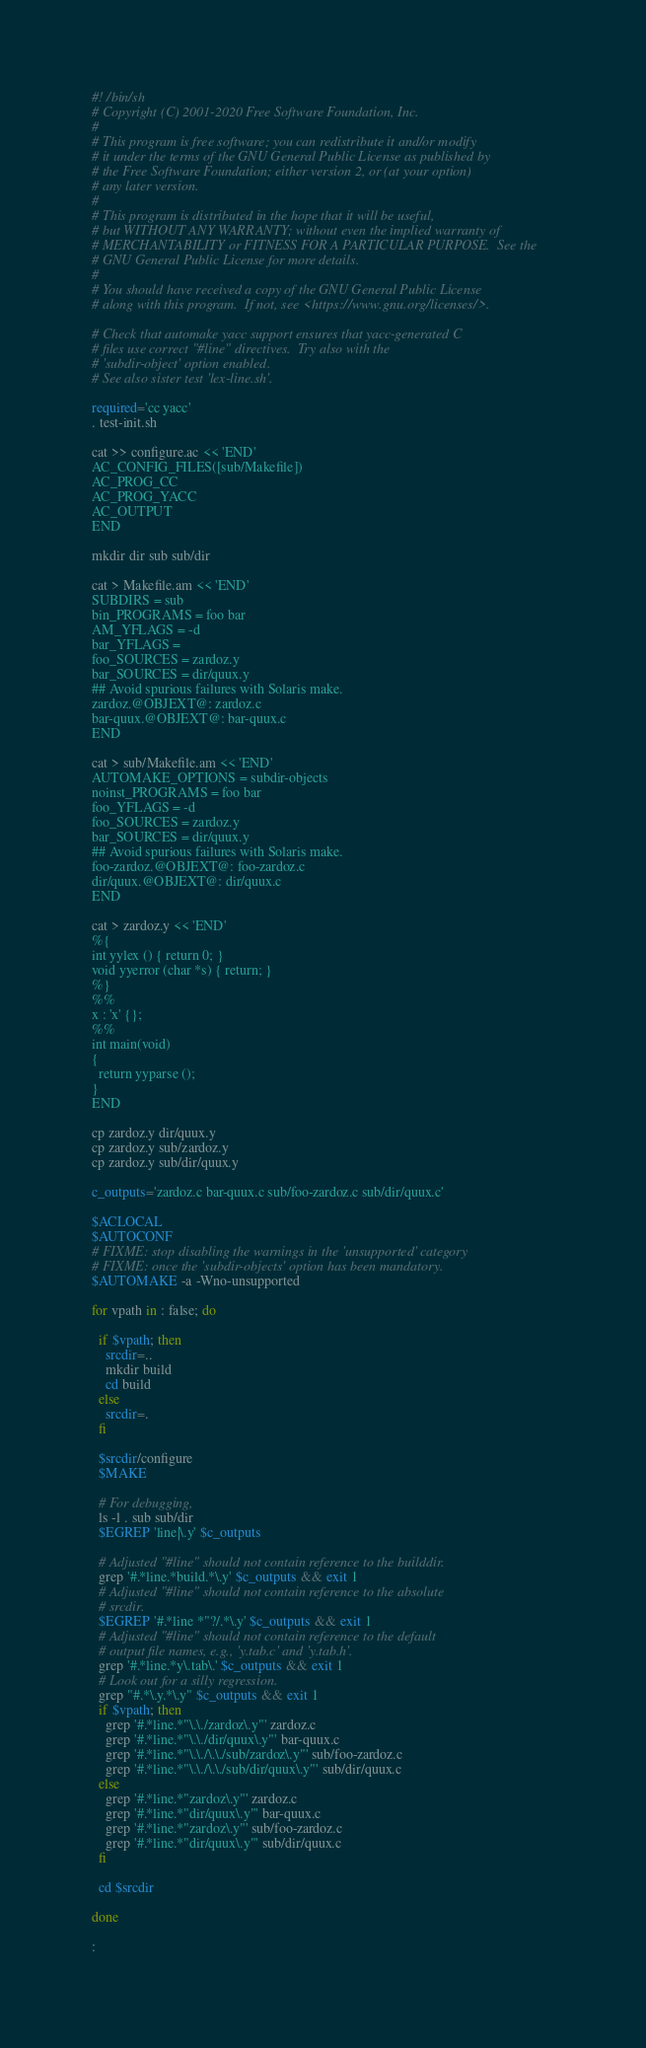<code> <loc_0><loc_0><loc_500><loc_500><_Bash_>#! /bin/sh
# Copyright (C) 2001-2020 Free Software Foundation, Inc.
#
# This program is free software; you can redistribute it and/or modify
# it under the terms of the GNU General Public License as published by
# the Free Software Foundation; either version 2, or (at your option)
# any later version.
#
# This program is distributed in the hope that it will be useful,
# but WITHOUT ANY WARRANTY; without even the implied warranty of
# MERCHANTABILITY or FITNESS FOR A PARTICULAR PURPOSE.  See the
# GNU General Public License for more details.
#
# You should have received a copy of the GNU General Public License
# along with this program.  If not, see <https://www.gnu.org/licenses/>.

# Check that automake yacc support ensures that yacc-generated C
# files use correct "#line" directives.  Try also with the
# 'subdir-object' option enabled.
# See also sister test 'lex-line.sh'.

required='cc yacc'
. test-init.sh

cat >> configure.ac << 'END'
AC_CONFIG_FILES([sub/Makefile])
AC_PROG_CC
AC_PROG_YACC
AC_OUTPUT
END

mkdir dir sub sub/dir

cat > Makefile.am << 'END'
SUBDIRS = sub
bin_PROGRAMS = foo bar
AM_YFLAGS = -d
bar_YFLAGS =
foo_SOURCES = zardoz.y
bar_SOURCES = dir/quux.y
## Avoid spurious failures with Solaris make.
zardoz.@OBJEXT@: zardoz.c
bar-quux.@OBJEXT@: bar-quux.c
END

cat > sub/Makefile.am << 'END'
AUTOMAKE_OPTIONS = subdir-objects
noinst_PROGRAMS = foo bar
foo_YFLAGS = -d
foo_SOURCES = zardoz.y
bar_SOURCES = dir/quux.y
## Avoid spurious failures with Solaris make.
foo-zardoz.@OBJEXT@: foo-zardoz.c
dir/quux.@OBJEXT@: dir/quux.c
END

cat > zardoz.y << 'END'
%{
int yylex () { return 0; }
void yyerror (char *s) { return; }
%}
%%
x : 'x' {};
%%
int main(void)
{
  return yyparse ();
}
END

cp zardoz.y dir/quux.y
cp zardoz.y sub/zardoz.y
cp zardoz.y sub/dir/quux.y

c_outputs='zardoz.c bar-quux.c sub/foo-zardoz.c sub/dir/quux.c'

$ACLOCAL
$AUTOCONF
# FIXME: stop disabling the warnings in the 'unsupported' category
# FIXME: once the 'subdir-objects' option has been mandatory.
$AUTOMAKE -a -Wno-unsupported

for vpath in : false; do

  if $vpath; then
    srcdir=..
    mkdir build
    cd build
  else
    srcdir=.
  fi

  $srcdir/configure
  $MAKE

  # For debugging,
  ls -l . sub sub/dir
  $EGREP 'line|\.y' $c_outputs

  # Adjusted "#line" should not contain reference to the builddir.
  grep '#.*line.*build.*\.y' $c_outputs && exit 1
  # Adjusted "#line" should not contain reference to the absolute
  # srcdir.
  $EGREP '#.*line *"?/.*\.y' $c_outputs && exit 1
  # Adjusted "#line" should not contain reference to the default
  # output file names, e.g., 'y.tab.c' and 'y.tab.h'.
  grep '#.*line.*y\.tab\.' $c_outputs && exit 1
  # Look out for a silly regression.
  grep "#.*\.y.*\.y" $c_outputs && exit 1
  if $vpath; then
    grep '#.*line.*"\.\./zardoz\.y"' zardoz.c
    grep '#.*line.*"\.\./dir/quux\.y"' bar-quux.c
    grep '#.*line.*"\.\./\.\./sub/zardoz\.y"' sub/foo-zardoz.c
    grep '#.*line.*"\.\./\.\./sub/dir/quux\.y"' sub/dir/quux.c
  else
    grep '#.*line.*"zardoz\.y"' zardoz.c
    grep '#.*line.*"dir/quux\.y"' bar-quux.c
    grep '#.*line.*"zardoz\.y"' sub/foo-zardoz.c
    grep '#.*line.*"dir/quux\.y"' sub/dir/quux.c
  fi

  cd $srcdir

done

:
</code> 